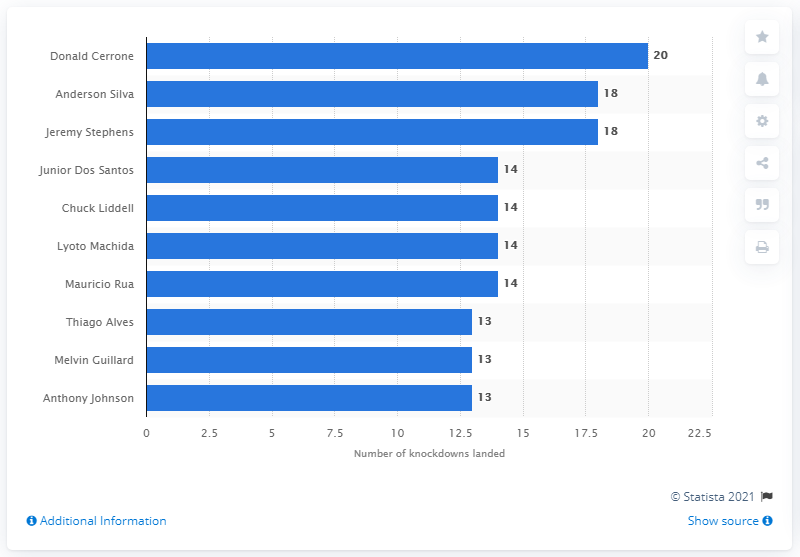Identify some key points in this picture. Anderson Silva and Jeremy Stephens have combined for a total of 18 knockdowns during their UFC fights. 